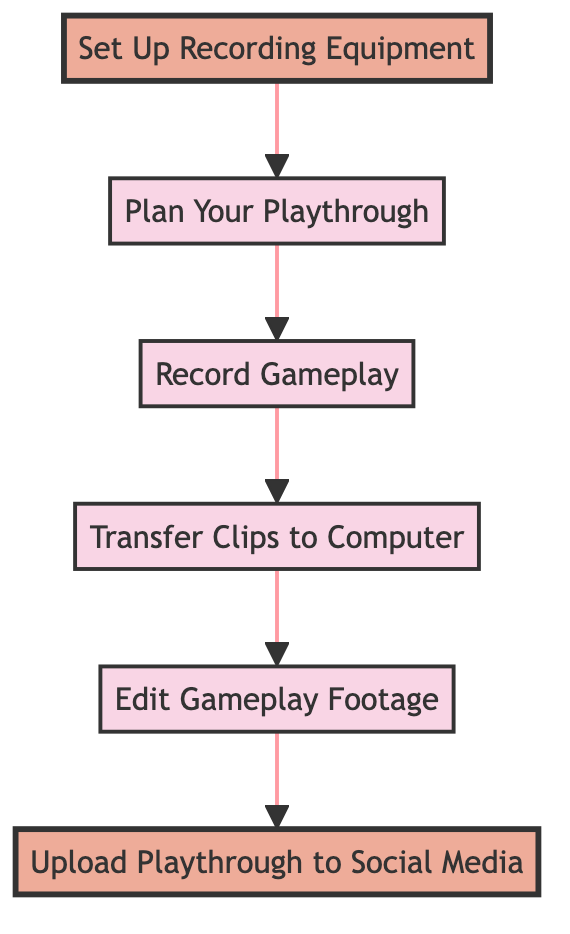What is the first step in the process? The first step in the diagram is represented at the bottom, which is "Set Up Recording Equipment." This is the initial action before proceeding to the next steps.
Answer: Set Up Recording Equipment How many nodes are in the diagram? To determine the number of nodes, we can count each distinct step represented in the flowchart. There are six steps or nodes listed in the diagram: Set Up Recording Equipment, Plan Your Playthrough, Record Gameplay, Transfer Clips to Computer, Edit Gameplay Footage, and Upload Playthrough to Social Media.
Answer: 6 What is the last step in the process? The last step in the flowchart is the final action that concludes the tutorial, which is "Upload Playthrough to Social Media." This indicates that after finishing the previous tasks, the final action is to share the gameplay online.
Answer: Upload Playthrough to Social Media What is the relationship between ‘Record Gameplay’ and ‘Edit Gameplay Footage’? ‘Record Gameplay’ leads directly to ‘Edit Gameplay Footage’ in the diagram. This indicates that after the gameplay is recorded, the next logical step is to edit that footage before sharing it.
Answer: Record Gameplay → Edit Gameplay Footage Which step comes directly after transferring clips to the computer? Following the step of "Transfer Clips to Computer," the next step indicated in the flowchart is "Edit Gameplay Footage." This means that after the clips have been transferred, the editing process begins.
Answer: Edit Gameplay Footage What is the second step in the process? The second step, following "Set Up Recording Equipment," is "Plan Your Playthrough." This indicates that after setting up the necessary equipment, you should plan what aspects of gameplay to showcase.
Answer: Plan Your Playthrough Is 'Edit Gameplay Footage' directly connected to 'Record Gameplay'? No, 'Edit Gameplay Footage' is not directly connected to 'Record Gameplay.' There is an intermediate step, which is 'Transfer Clips to Computer,' that must occur between recording gameplay and editing it.
Answer: No What equipment is set up first in the process? The process begins with setting up recording equipment, which includes ensuring that all necessary devices like consoles, capture cards, microphones, and software are properly connected and configured.
Answer: Recording equipment 